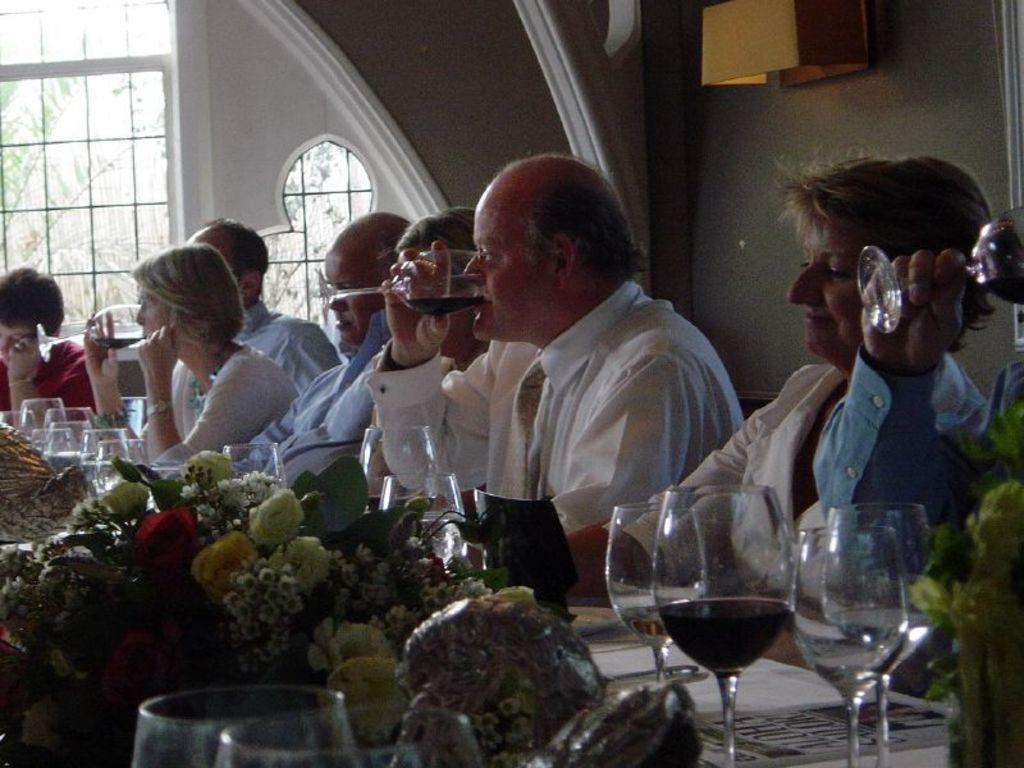What are the people in the image doing? The people in the image are sitting and having drinks. What is in front of the people? There is a table in front of the people. What can be found on the table? There are different items on the table. What type of garden can be seen in the background of the image? There is no garden present in the image; it only shows people sitting at a table with drinks. 